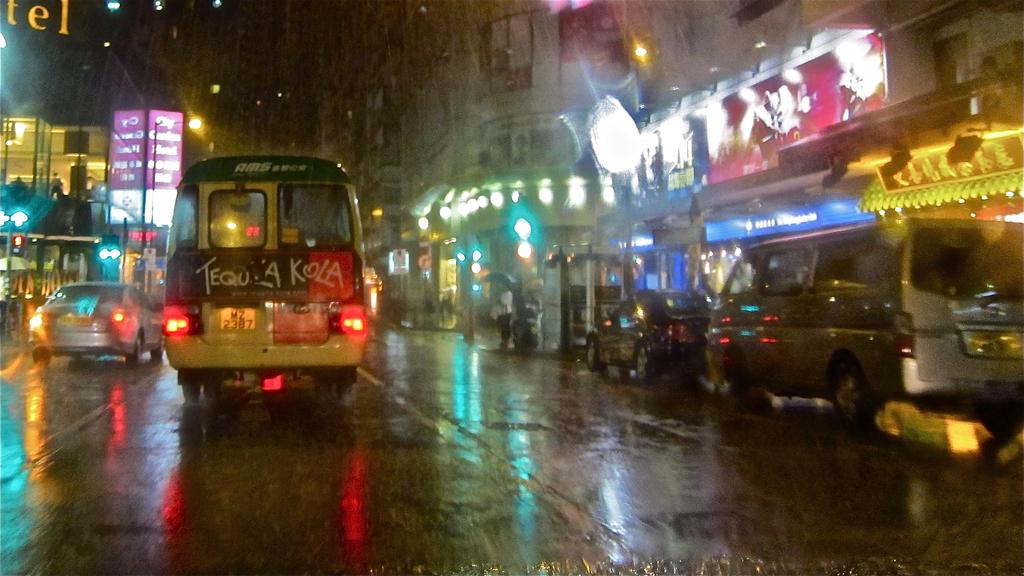What's the ad on the back of the bus?
Provide a succinct answer. Tequila kola. 